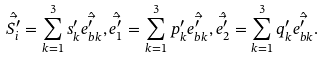Convert formula to latex. <formula><loc_0><loc_0><loc_500><loc_500>\hat { \vec { S ^ { \prime } _ { i } } } = \sum _ { k = 1 } ^ { 3 } s ^ { \prime } _ { k } \hat { \vec { e ^ { \prime } _ { b k } } } , \hat { \vec { e ^ { \prime } _ { 1 } } } = \sum _ { k = 1 } ^ { 3 } p ^ { \prime } _ { k } \hat { \vec { e ^ { \prime } _ { b k } } } , \hat { \vec { e ^ { \prime } _ { 2 } } } = \sum _ { k = 1 } ^ { 3 } q ^ { \prime } _ { k } \hat { \vec { e ^ { \prime } _ { b k } } } .</formula> 